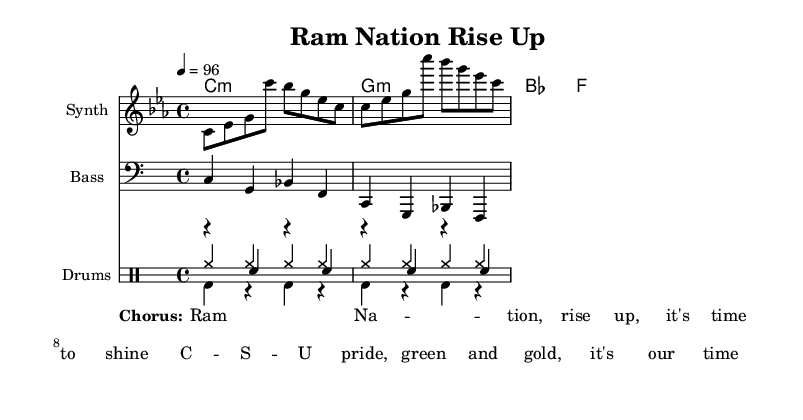What is the key signature of this music? The key signature is C minor, which has three flats (B flat, E flat, and A flat) as indicated by the positioning of the flats at the beginning of the staff.
Answer: C minor What is the time signature of this music? The time signature is indicated by the numbers at the beginning of the staff, showing that there are four beats in each measure, with a quarter note receiving one beat.
Answer: 4/4 What is the tempo marking of this music? The tempo is indicated at the beginning, showing a speed of 96 beats per minute, which sets the pace for the performance of the piece.
Answer: 96 What instruments are featured in the score? The score consists of a Synth for the melody, Bass for the bassline, and a Drum ensemble that includes Hi-Hat, Kick, and Snare drums, as indicated by the instrument names in the staff headers.
Answer: Synth, Bass, Drums What chords are used in the song? The chord progression listed in the chord names section indicates C minor, G minor, B flat, and F, showing the harmonic structure of the piece.
Answer: C minor, G minor, B flat, F How many lines does the drum staff have? The drum staff is indicated to have three lines, as specified by the override setting in the staff configuration, which adjusts the visual layout for drum notation.
Answer: 3 What is the main theme of the chorus? The lyrics in the chorus emphasize school spirit and pride for Colorado State University, focusing on rising up and shining as part of Ram Nation.
Answer: Ram Nation, rise up 